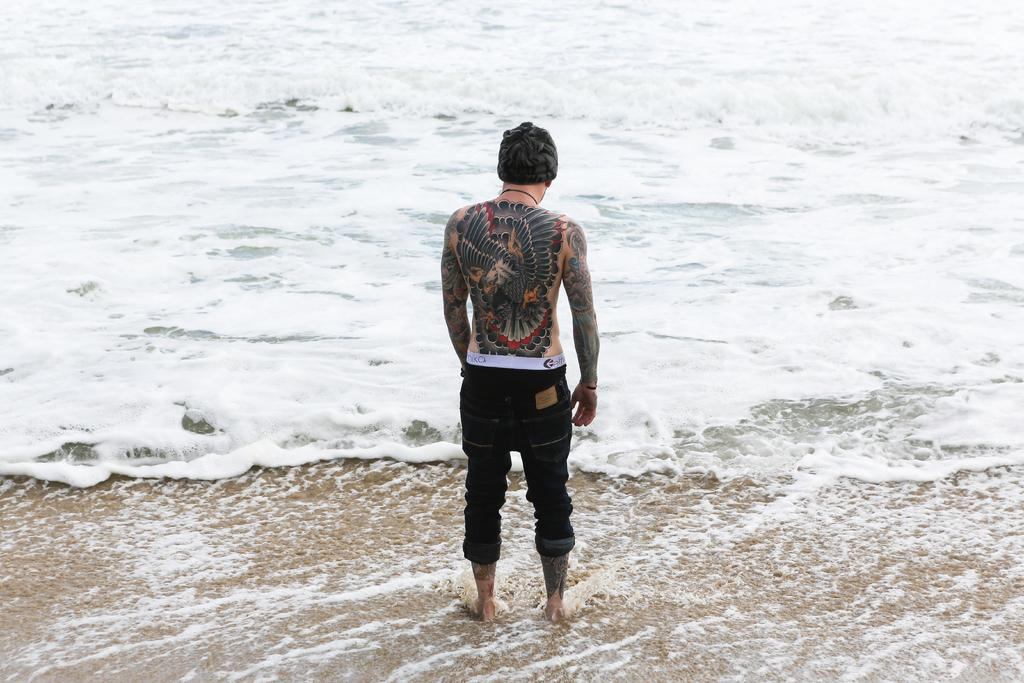What is the main subject of the image? There is a person in the image. Can you describe any distinguishing features of the person? The person has visible tattoos. What is the person doing in the image? The person is standing. What can be seen in the background of the image? There are waves in the water visible in the image. What type of dinosaur can be seen swimming in the water in the image? There are no dinosaurs present in the image; it features a person standing near waves in the water. Can you tell me who the person's partner is in the image? There is no information about a partner or any other person in the image, as it only features one person with visible tattoos standing near waves in the water. 